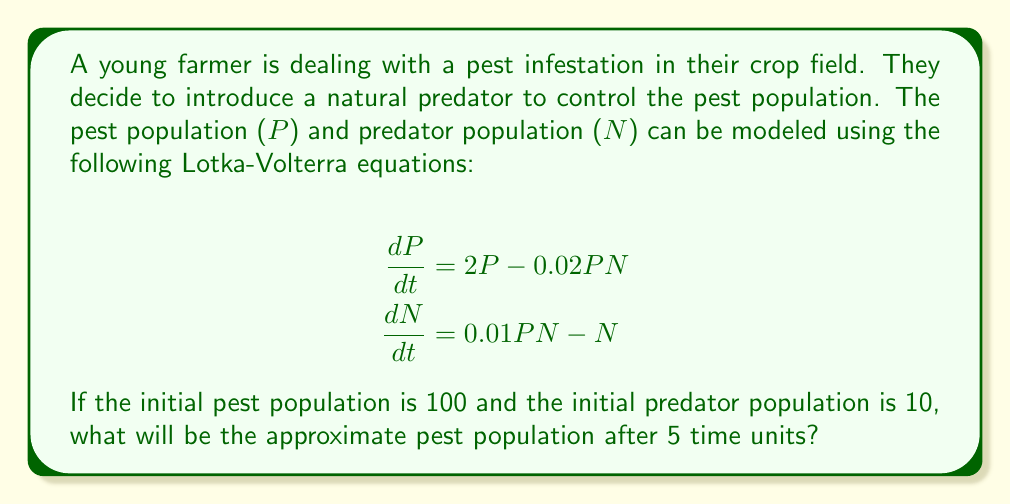Help me with this question. To solve this problem, we need to use numerical methods to approximate the solution of the system of differential equations. We'll use the Euler method for simplicity.

Step 1: Set up the initial conditions and time step
P(0) = 100
N(0) = 10
Δt = 0.1 (we'll use 50 steps to reach t = 5)

Step 2: Define the functions for dP/dt and dN/dt
f(P, N) = 2P - 0.02PN
g(P, N) = 0.01PN - N

Step 3: Apply the Euler method iteratively
For i = 1 to 50:
    P(i) = P(i-1) + Δt * f(P(i-1), N(i-1))
    N(i) = N(i-1) + Δt * g(P(i-1), N(i-1))

Step 4: Calculate the values (showing first few iterations)
t = 0.1: P ≈ 119.8, N ≈ 10.9
t = 0.2: P ≈ 141.9, N ≈ 12.5
t = 0.3: P ≈ 166.1, N ≈ 14.8
...

Step 5: Continue until t = 5
After 50 iterations, we reach t = 5 with:
P(5) ≈ 24.6
N(5) ≈ 97.2

Therefore, the approximate pest population after 5 time units is about 25 (rounded to the nearest whole number).
Answer: 25 pests 